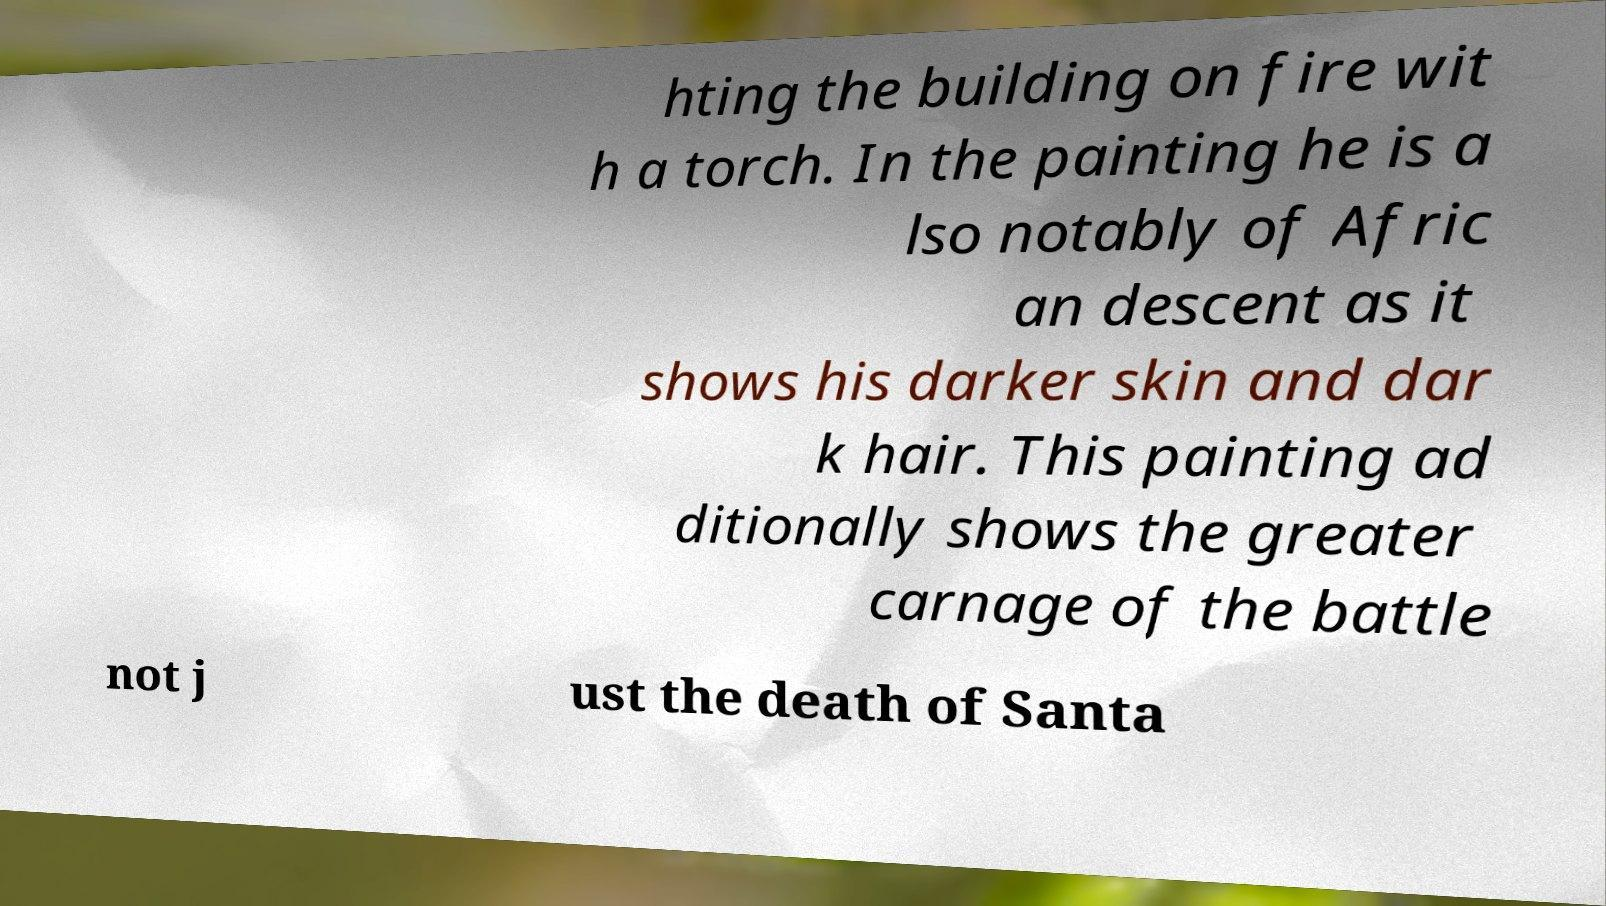What messages or text are displayed in this image? I need them in a readable, typed format. hting the building on fire wit h a torch. In the painting he is a lso notably of Afric an descent as it shows his darker skin and dar k hair. This painting ad ditionally shows the greater carnage of the battle not j ust the death of Santa 